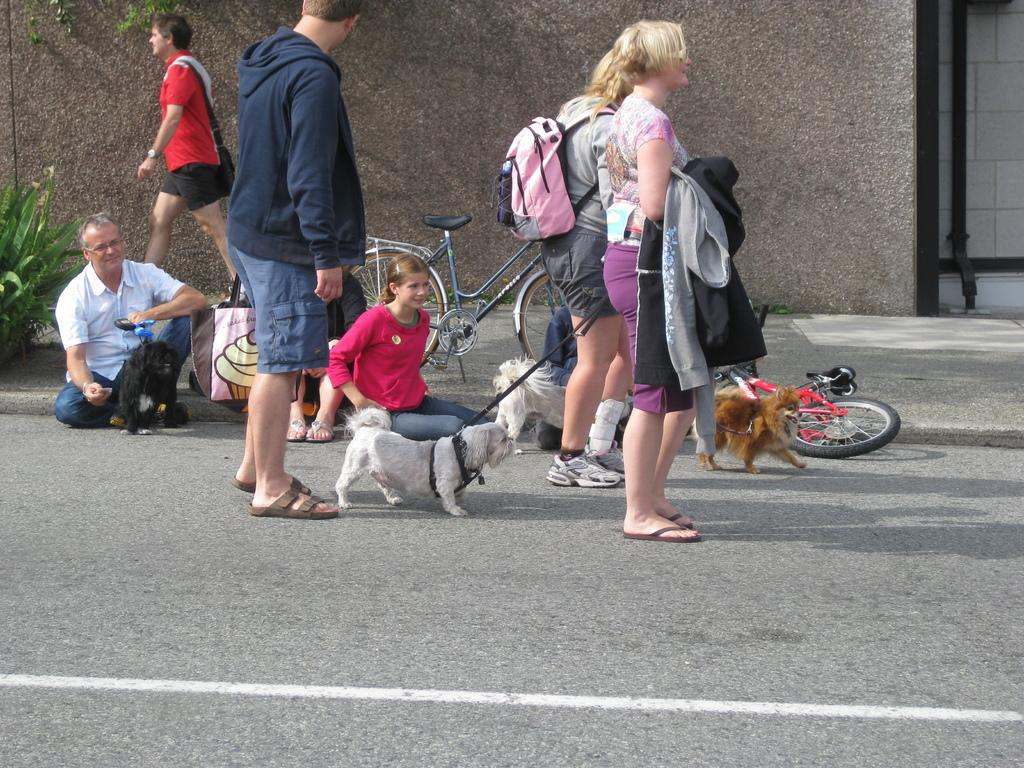What type of structure can be seen in the image? There is a wall in the image. What else is visible in the image besides the wall? There is a road, a bicycle, people standing on the road, and dogs in the image. What is the bicycle doing on the road? The bicycle is on the road, but the specific action of the bicycle is not mentioned in the facts. Can you describe the people in the image? The people are standing on the road. What type of box is being carried by the father in the image? There is no father or box present in the image. What type of police vehicle can be seen in the image? There is no police vehicle present in the image. 